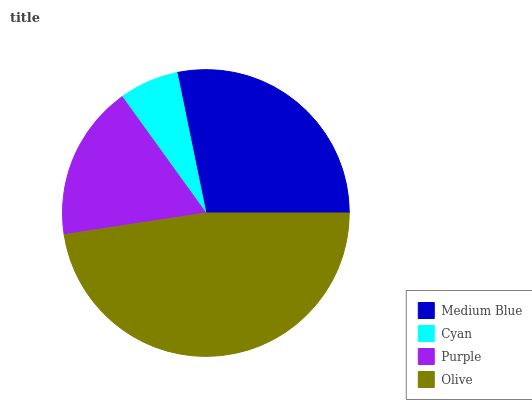Is Cyan the minimum?
Answer yes or no. Yes. Is Olive the maximum?
Answer yes or no. Yes. Is Purple the minimum?
Answer yes or no. No. Is Purple the maximum?
Answer yes or no. No. Is Purple greater than Cyan?
Answer yes or no. Yes. Is Cyan less than Purple?
Answer yes or no. Yes. Is Cyan greater than Purple?
Answer yes or no. No. Is Purple less than Cyan?
Answer yes or no. No. Is Medium Blue the high median?
Answer yes or no. Yes. Is Purple the low median?
Answer yes or no. Yes. Is Purple the high median?
Answer yes or no. No. Is Medium Blue the low median?
Answer yes or no. No. 